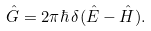<formula> <loc_0><loc_0><loc_500><loc_500>\hat { G } = 2 \pi \hbar { \, } \delta ( \hat { E } - \hat { H } ) .</formula> 